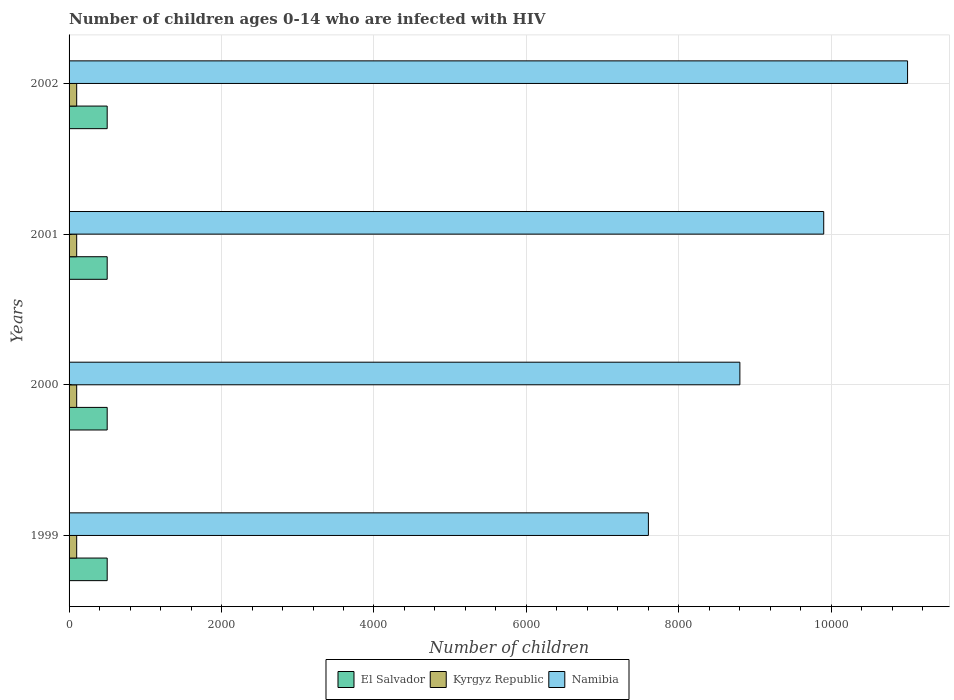How many different coloured bars are there?
Make the answer very short. 3. How many groups of bars are there?
Your answer should be compact. 4. How many bars are there on the 2nd tick from the top?
Ensure brevity in your answer.  3. What is the label of the 1st group of bars from the top?
Offer a terse response. 2002. In how many cases, is the number of bars for a given year not equal to the number of legend labels?
Provide a succinct answer. 0. What is the number of HIV infected children in Kyrgyz Republic in 2002?
Offer a very short reply. 100. Across all years, what is the maximum number of HIV infected children in Kyrgyz Republic?
Your answer should be very brief. 100. Across all years, what is the minimum number of HIV infected children in Kyrgyz Republic?
Ensure brevity in your answer.  100. In which year was the number of HIV infected children in Namibia maximum?
Offer a very short reply. 2002. In which year was the number of HIV infected children in Kyrgyz Republic minimum?
Offer a very short reply. 1999. What is the total number of HIV infected children in Namibia in the graph?
Keep it short and to the point. 3.73e+04. What is the difference between the number of HIV infected children in El Salvador in 2000 and the number of HIV infected children in Namibia in 1999?
Make the answer very short. -7100. What is the average number of HIV infected children in El Salvador per year?
Your answer should be compact. 500. In the year 2000, what is the difference between the number of HIV infected children in El Salvador and number of HIV infected children in Namibia?
Provide a succinct answer. -8300. What does the 3rd bar from the top in 2002 represents?
Offer a very short reply. El Salvador. What does the 3rd bar from the bottom in 2000 represents?
Give a very brief answer. Namibia. Is it the case that in every year, the sum of the number of HIV infected children in Kyrgyz Republic and number of HIV infected children in El Salvador is greater than the number of HIV infected children in Namibia?
Offer a terse response. No. Are all the bars in the graph horizontal?
Provide a short and direct response. Yes. How many years are there in the graph?
Make the answer very short. 4. Are the values on the major ticks of X-axis written in scientific E-notation?
Your answer should be very brief. No. Does the graph contain grids?
Provide a succinct answer. Yes. What is the title of the graph?
Offer a terse response. Number of children ages 0-14 who are infected with HIV. What is the label or title of the X-axis?
Offer a very short reply. Number of children. What is the label or title of the Y-axis?
Your answer should be very brief. Years. What is the Number of children of Namibia in 1999?
Ensure brevity in your answer.  7600. What is the Number of children in Namibia in 2000?
Your answer should be very brief. 8800. What is the Number of children of Kyrgyz Republic in 2001?
Keep it short and to the point. 100. What is the Number of children in Namibia in 2001?
Provide a succinct answer. 9900. What is the Number of children in Namibia in 2002?
Offer a very short reply. 1.10e+04. Across all years, what is the maximum Number of children in Namibia?
Provide a short and direct response. 1.10e+04. Across all years, what is the minimum Number of children in El Salvador?
Provide a short and direct response. 500. Across all years, what is the minimum Number of children in Kyrgyz Republic?
Offer a very short reply. 100. Across all years, what is the minimum Number of children in Namibia?
Make the answer very short. 7600. What is the total Number of children in Namibia in the graph?
Provide a succinct answer. 3.73e+04. What is the difference between the Number of children in El Salvador in 1999 and that in 2000?
Keep it short and to the point. 0. What is the difference between the Number of children in Namibia in 1999 and that in 2000?
Give a very brief answer. -1200. What is the difference between the Number of children of Kyrgyz Republic in 1999 and that in 2001?
Your answer should be very brief. 0. What is the difference between the Number of children in Namibia in 1999 and that in 2001?
Ensure brevity in your answer.  -2300. What is the difference between the Number of children in El Salvador in 1999 and that in 2002?
Your response must be concise. 0. What is the difference between the Number of children in Kyrgyz Republic in 1999 and that in 2002?
Offer a terse response. 0. What is the difference between the Number of children in Namibia in 1999 and that in 2002?
Your response must be concise. -3400. What is the difference between the Number of children of El Salvador in 2000 and that in 2001?
Your answer should be very brief. 0. What is the difference between the Number of children of Kyrgyz Republic in 2000 and that in 2001?
Make the answer very short. 0. What is the difference between the Number of children in Namibia in 2000 and that in 2001?
Offer a very short reply. -1100. What is the difference between the Number of children in El Salvador in 2000 and that in 2002?
Offer a terse response. 0. What is the difference between the Number of children in Namibia in 2000 and that in 2002?
Provide a succinct answer. -2200. What is the difference between the Number of children in El Salvador in 2001 and that in 2002?
Provide a short and direct response. 0. What is the difference between the Number of children in Namibia in 2001 and that in 2002?
Provide a short and direct response. -1100. What is the difference between the Number of children in El Salvador in 1999 and the Number of children in Kyrgyz Republic in 2000?
Provide a succinct answer. 400. What is the difference between the Number of children of El Salvador in 1999 and the Number of children of Namibia in 2000?
Offer a very short reply. -8300. What is the difference between the Number of children in Kyrgyz Republic in 1999 and the Number of children in Namibia in 2000?
Make the answer very short. -8700. What is the difference between the Number of children in El Salvador in 1999 and the Number of children in Kyrgyz Republic in 2001?
Provide a succinct answer. 400. What is the difference between the Number of children of El Salvador in 1999 and the Number of children of Namibia in 2001?
Offer a terse response. -9400. What is the difference between the Number of children in Kyrgyz Republic in 1999 and the Number of children in Namibia in 2001?
Your answer should be very brief. -9800. What is the difference between the Number of children of El Salvador in 1999 and the Number of children of Kyrgyz Republic in 2002?
Offer a very short reply. 400. What is the difference between the Number of children in El Salvador in 1999 and the Number of children in Namibia in 2002?
Ensure brevity in your answer.  -1.05e+04. What is the difference between the Number of children in Kyrgyz Republic in 1999 and the Number of children in Namibia in 2002?
Offer a terse response. -1.09e+04. What is the difference between the Number of children in El Salvador in 2000 and the Number of children in Kyrgyz Republic in 2001?
Your answer should be very brief. 400. What is the difference between the Number of children of El Salvador in 2000 and the Number of children of Namibia in 2001?
Offer a terse response. -9400. What is the difference between the Number of children of Kyrgyz Republic in 2000 and the Number of children of Namibia in 2001?
Offer a terse response. -9800. What is the difference between the Number of children in El Salvador in 2000 and the Number of children in Namibia in 2002?
Provide a succinct answer. -1.05e+04. What is the difference between the Number of children in Kyrgyz Republic in 2000 and the Number of children in Namibia in 2002?
Offer a terse response. -1.09e+04. What is the difference between the Number of children of El Salvador in 2001 and the Number of children of Kyrgyz Republic in 2002?
Your answer should be very brief. 400. What is the difference between the Number of children in El Salvador in 2001 and the Number of children in Namibia in 2002?
Give a very brief answer. -1.05e+04. What is the difference between the Number of children of Kyrgyz Republic in 2001 and the Number of children of Namibia in 2002?
Offer a very short reply. -1.09e+04. What is the average Number of children in Namibia per year?
Make the answer very short. 9325. In the year 1999, what is the difference between the Number of children of El Salvador and Number of children of Kyrgyz Republic?
Make the answer very short. 400. In the year 1999, what is the difference between the Number of children in El Salvador and Number of children in Namibia?
Your answer should be very brief. -7100. In the year 1999, what is the difference between the Number of children of Kyrgyz Republic and Number of children of Namibia?
Provide a succinct answer. -7500. In the year 2000, what is the difference between the Number of children of El Salvador and Number of children of Namibia?
Keep it short and to the point. -8300. In the year 2000, what is the difference between the Number of children in Kyrgyz Republic and Number of children in Namibia?
Your answer should be compact. -8700. In the year 2001, what is the difference between the Number of children in El Salvador and Number of children in Kyrgyz Republic?
Give a very brief answer. 400. In the year 2001, what is the difference between the Number of children of El Salvador and Number of children of Namibia?
Offer a very short reply. -9400. In the year 2001, what is the difference between the Number of children of Kyrgyz Republic and Number of children of Namibia?
Your response must be concise. -9800. In the year 2002, what is the difference between the Number of children in El Salvador and Number of children in Namibia?
Offer a terse response. -1.05e+04. In the year 2002, what is the difference between the Number of children of Kyrgyz Republic and Number of children of Namibia?
Make the answer very short. -1.09e+04. What is the ratio of the Number of children in El Salvador in 1999 to that in 2000?
Provide a short and direct response. 1. What is the ratio of the Number of children of Namibia in 1999 to that in 2000?
Provide a short and direct response. 0.86. What is the ratio of the Number of children in El Salvador in 1999 to that in 2001?
Your answer should be very brief. 1. What is the ratio of the Number of children of Namibia in 1999 to that in 2001?
Your response must be concise. 0.77. What is the ratio of the Number of children of Kyrgyz Republic in 1999 to that in 2002?
Your answer should be very brief. 1. What is the ratio of the Number of children of Namibia in 1999 to that in 2002?
Offer a very short reply. 0.69. What is the ratio of the Number of children in El Salvador in 2000 to that in 2002?
Your answer should be compact. 1. What is the ratio of the Number of children of Kyrgyz Republic in 2000 to that in 2002?
Your response must be concise. 1. What is the ratio of the Number of children of Namibia in 2000 to that in 2002?
Make the answer very short. 0.8. What is the ratio of the Number of children in El Salvador in 2001 to that in 2002?
Provide a short and direct response. 1. What is the ratio of the Number of children of Kyrgyz Republic in 2001 to that in 2002?
Keep it short and to the point. 1. What is the difference between the highest and the second highest Number of children of El Salvador?
Ensure brevity in your answer.  0. What is the difference between the highest and the second highest Number of children of Namibia?
Your response must be concise. 1100. What is the difference between the highest and the lowest Number of children in Kyrgyz Republic?
Keep it short and to the point. 0. What is the difference between the highest and the lowest Number of children of Namibia?
Ensure brevity in your answer.  3400. 